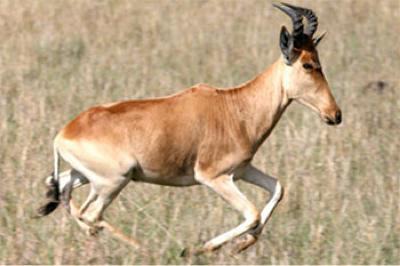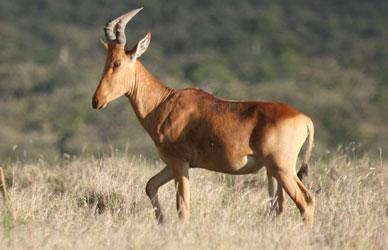The first image is the image on the left, the second image is the image on the right. Examine the images to the left and right. Is the description "Each image includes exactly one upright (standing) horned animal with its body in profile." accurate? Answer yes or no. Yes. 